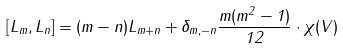Convert formula to latex. <formula><loc_0><loc_0><loc_500><loc_500>[ L _ { m } , L _ { n } ] = ( m - n ) L _ { m + n } + \delta _ { m , - n } \frac { m ( m ^ { 2 } - 1 ) } { 1 2 } \cdot \chi ( V )</formula> 